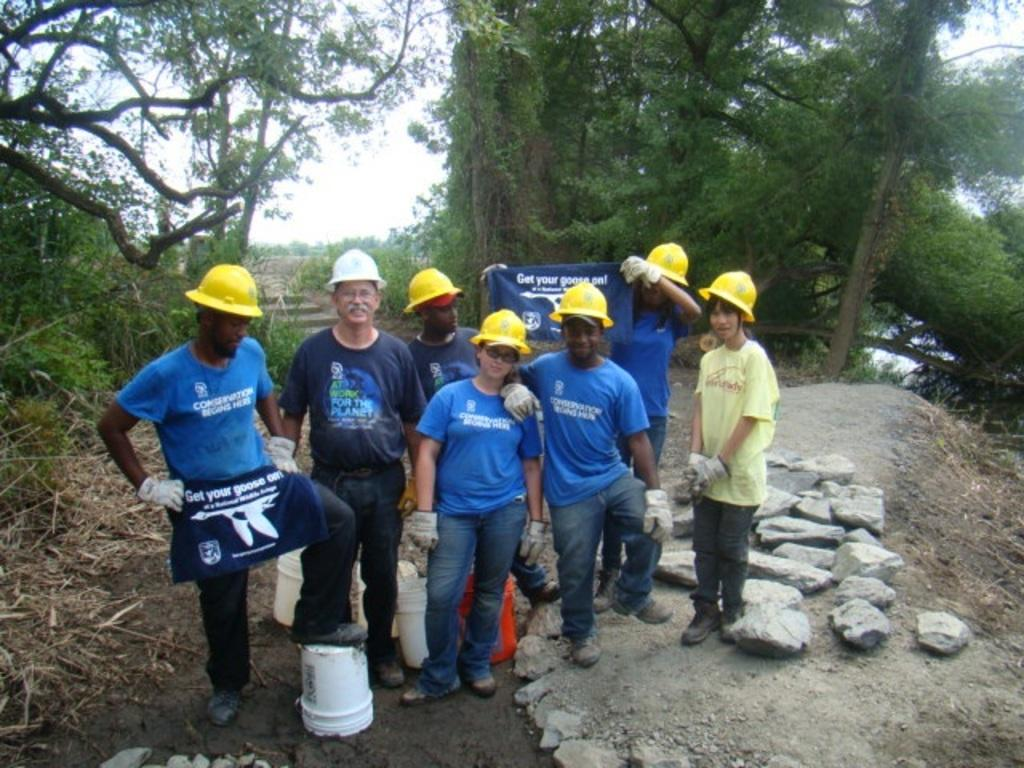<image>
Create a compact narrative representing the image presented. People posing in front of a banner which says "Get your goose on!". 